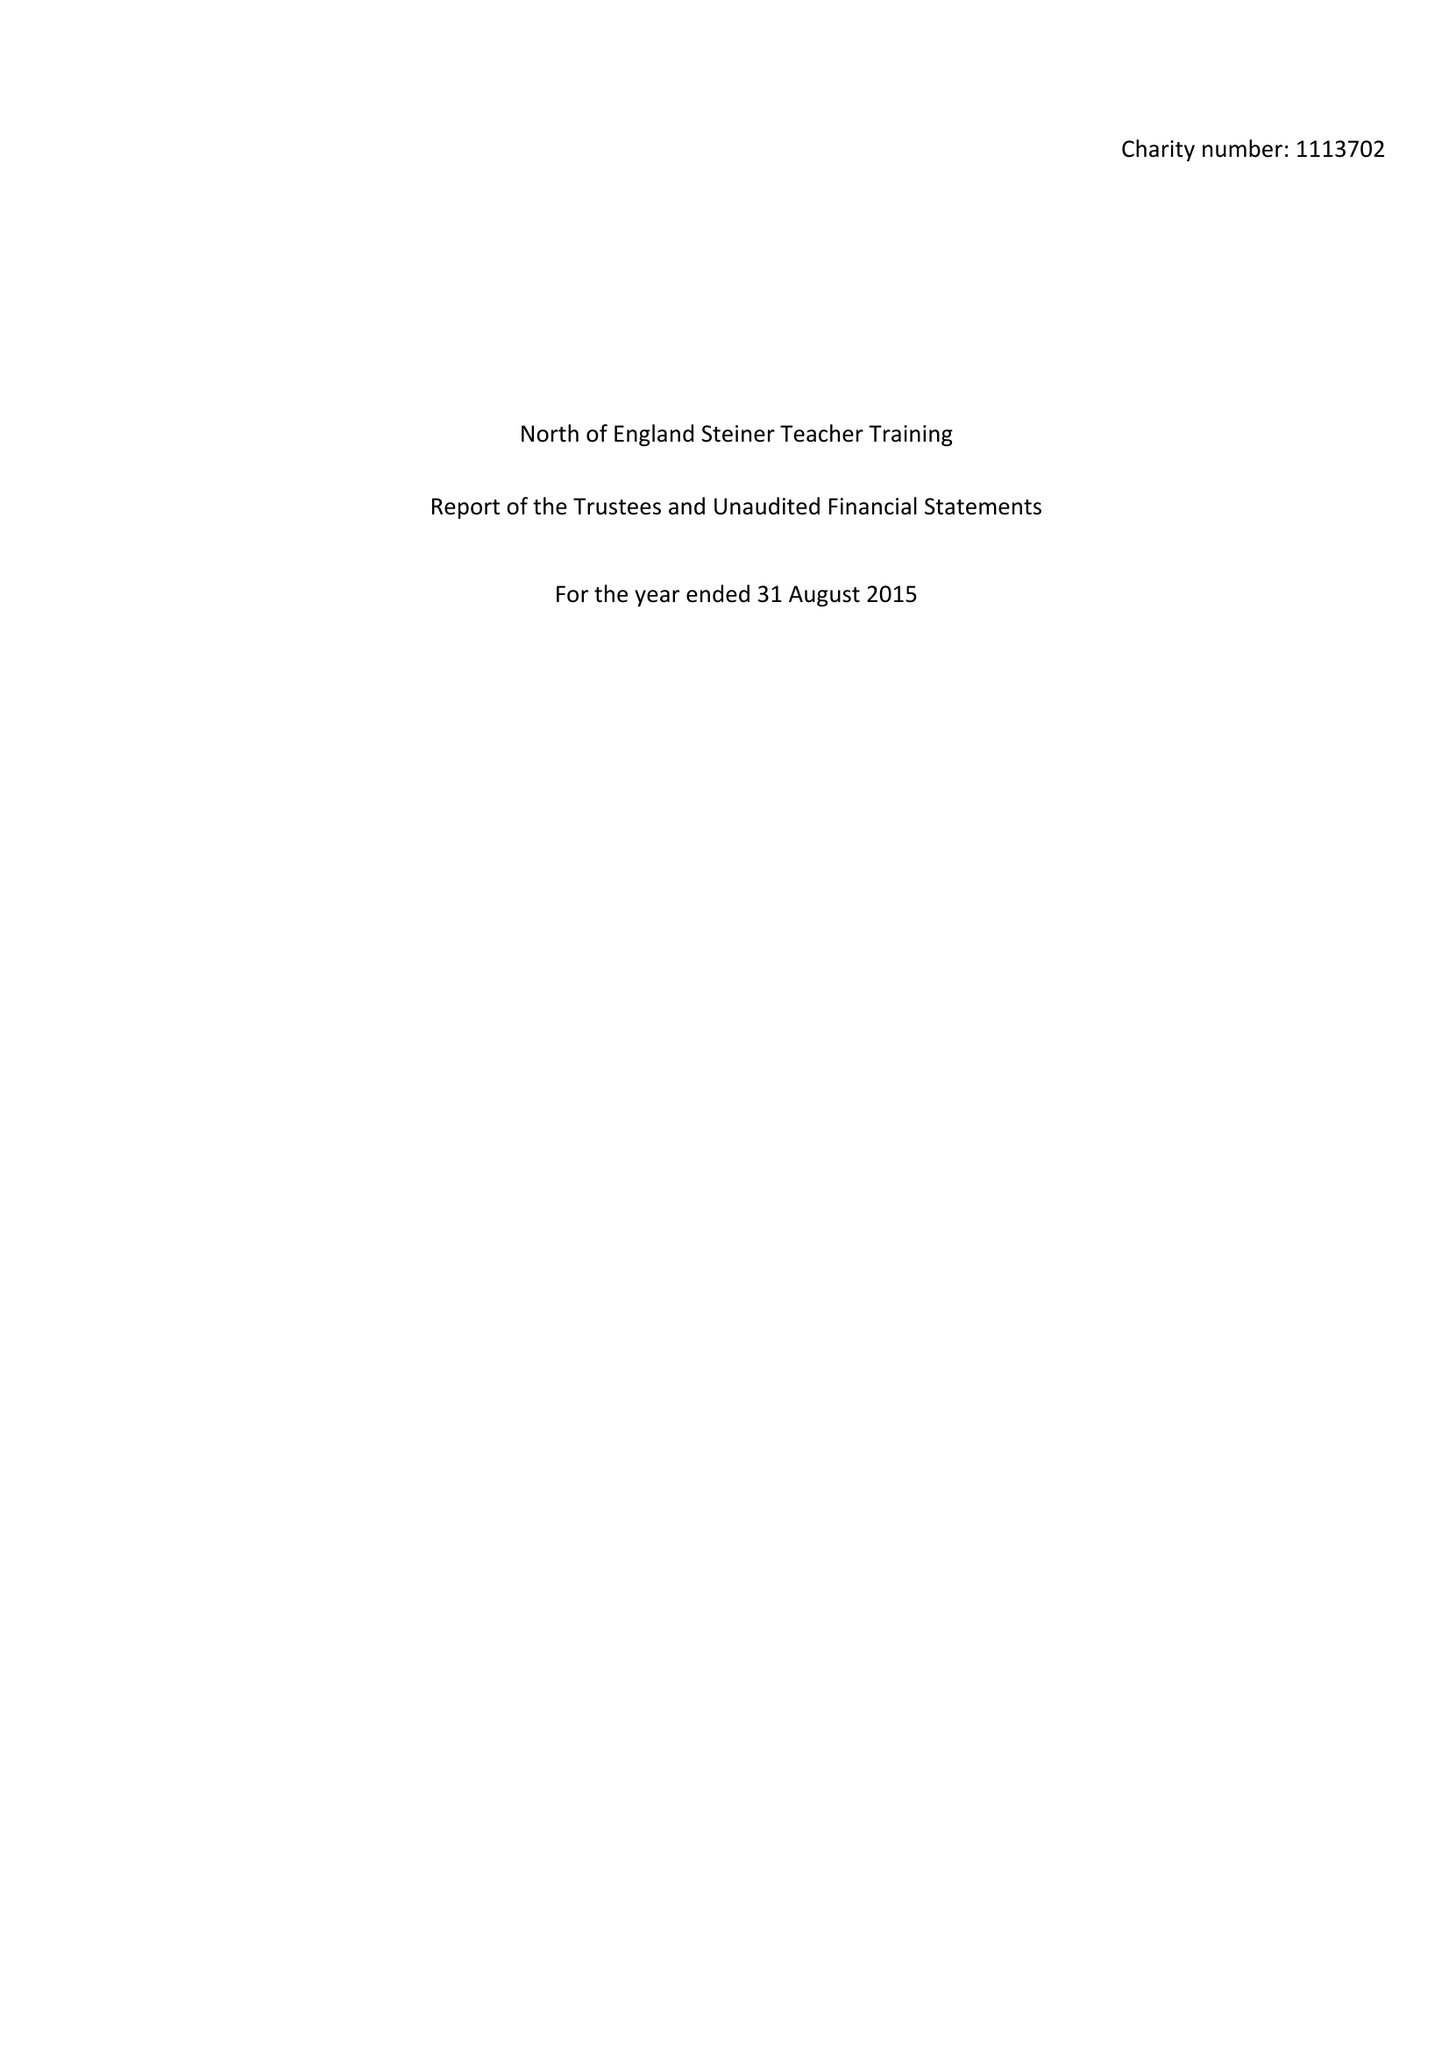What is the value for the address__post_town?
Answer the question using a single word or phrase. YORK 